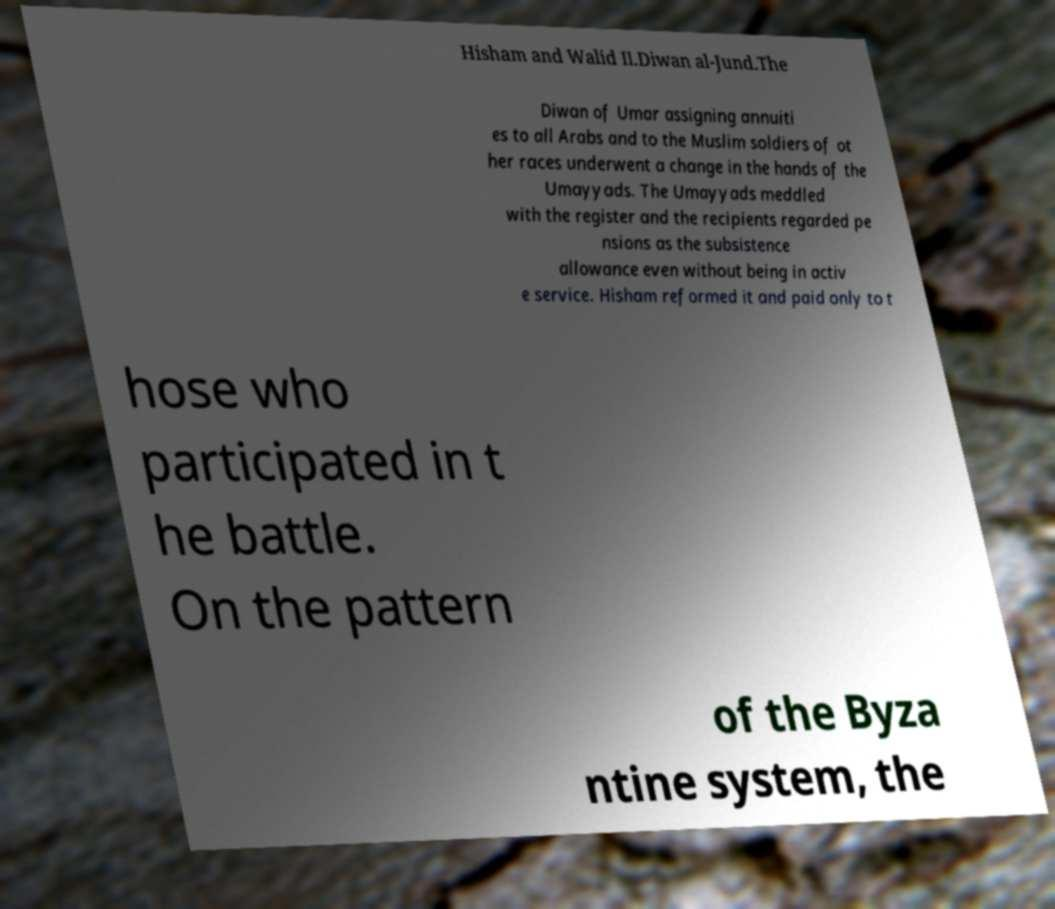Can you read and provide the text displayed in the image?This photo seems to have some interesting text. Can you extract and type it out for me? Hisham and Walid II.Diwan al-Jund.The Diwan of Umar assigning annuiti es to all Arabs and to the Muslim soldiers of ot her races underwent a change in the hands of the Umayyads. The Umayyads meddled with the register and the recipients regarded pe nsions as the subsistence allowance even without being in activ e service. Hisham reformed it and paid only to t hose who participated in t he battle. On the pattern of the Byza ntine system, the 